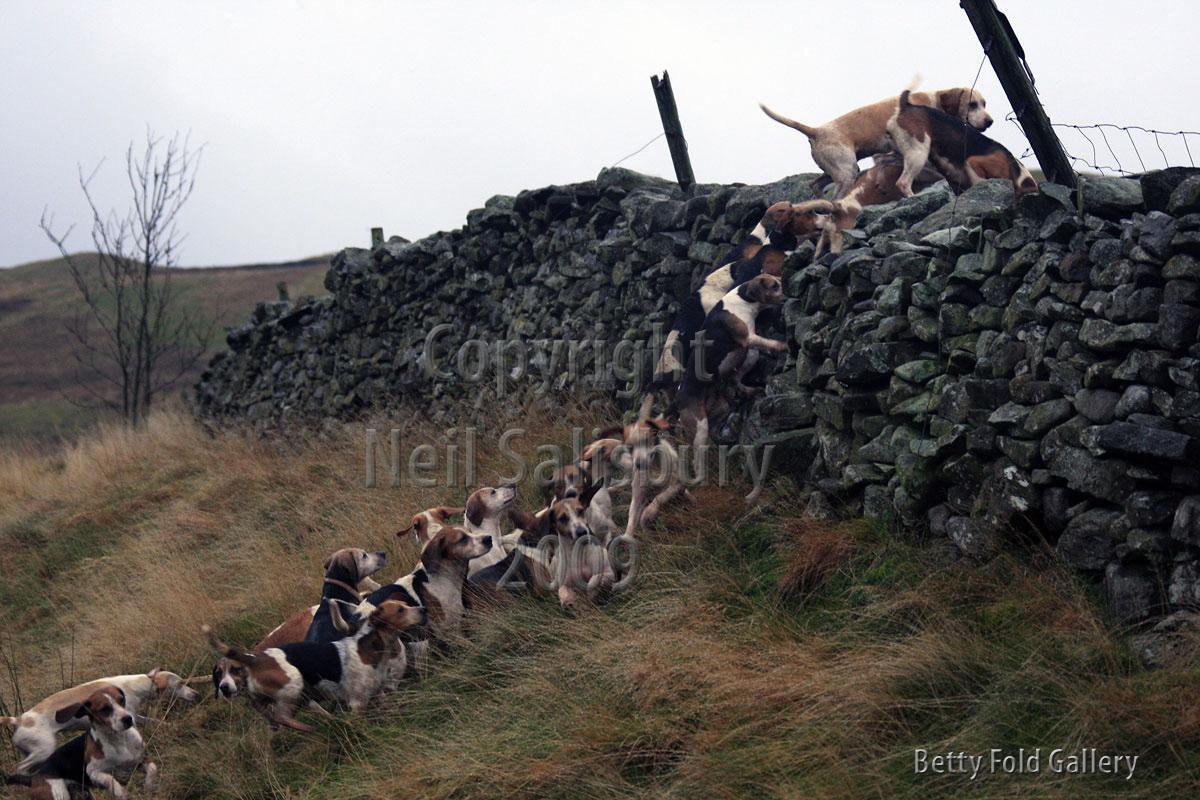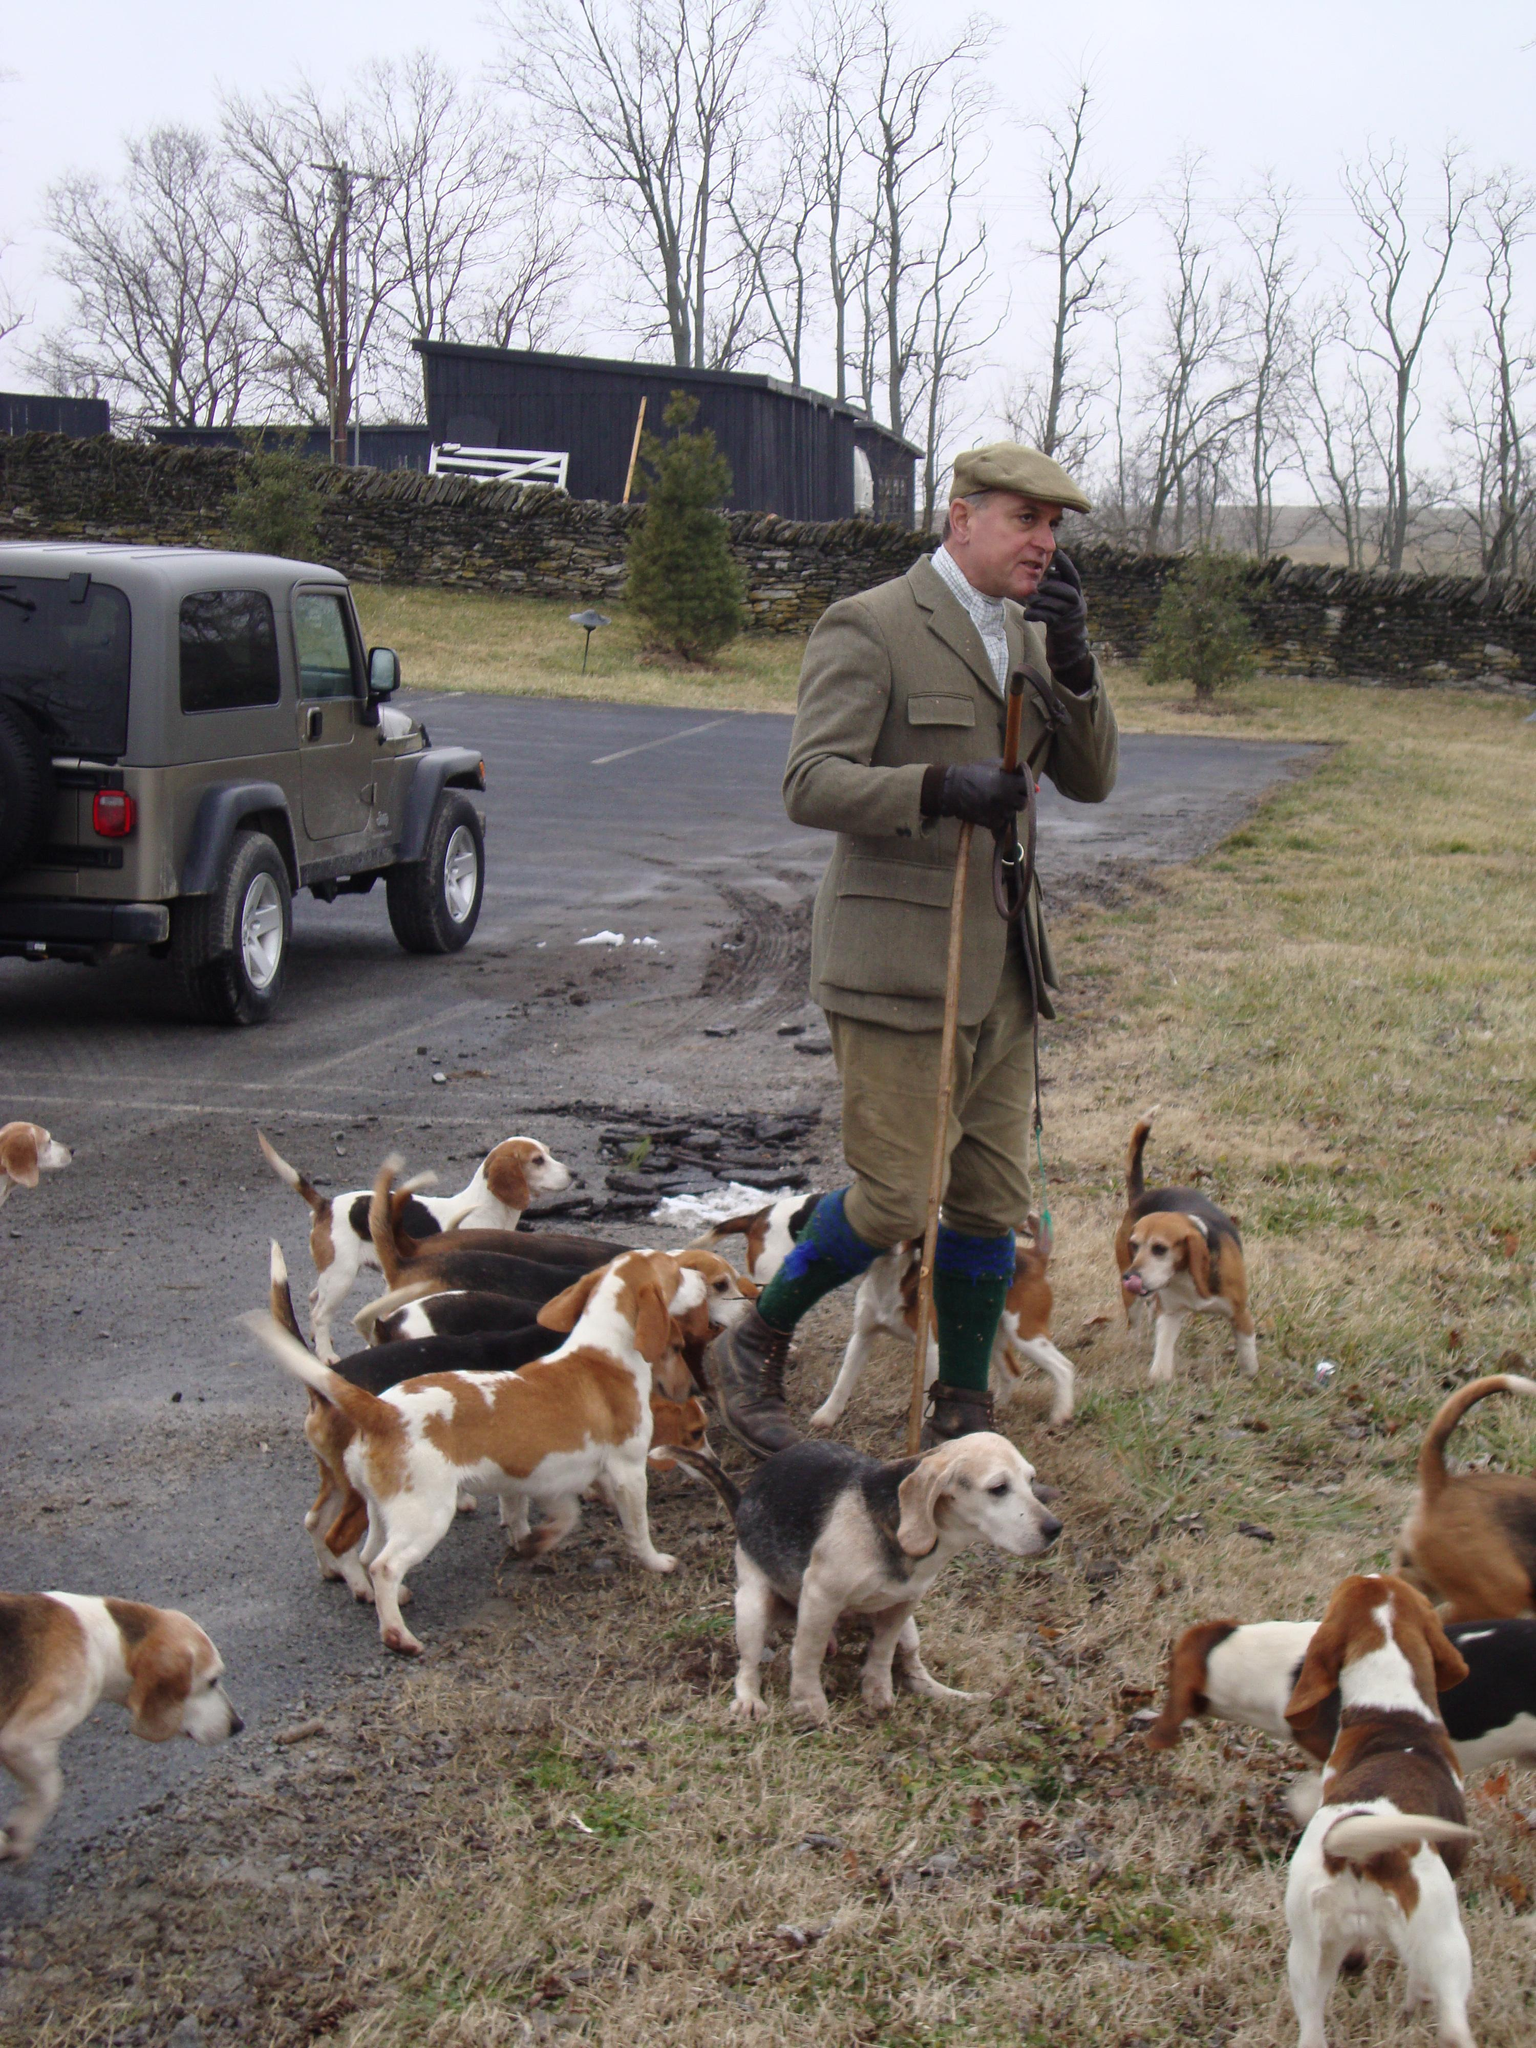The first image is the image on the left, the second image is the image on the right. For the images displayed, is the sentence "there is exactly one person in the image on the left" factually correct? Answer yes or no. No. The first image is the image on the left, the second image is the image on the right. Evaluate the accuracy of this statement regarding the images: "There are dogs near a vehicle parked on the roadway.". Is it true? Answer yes or no. Yes. 